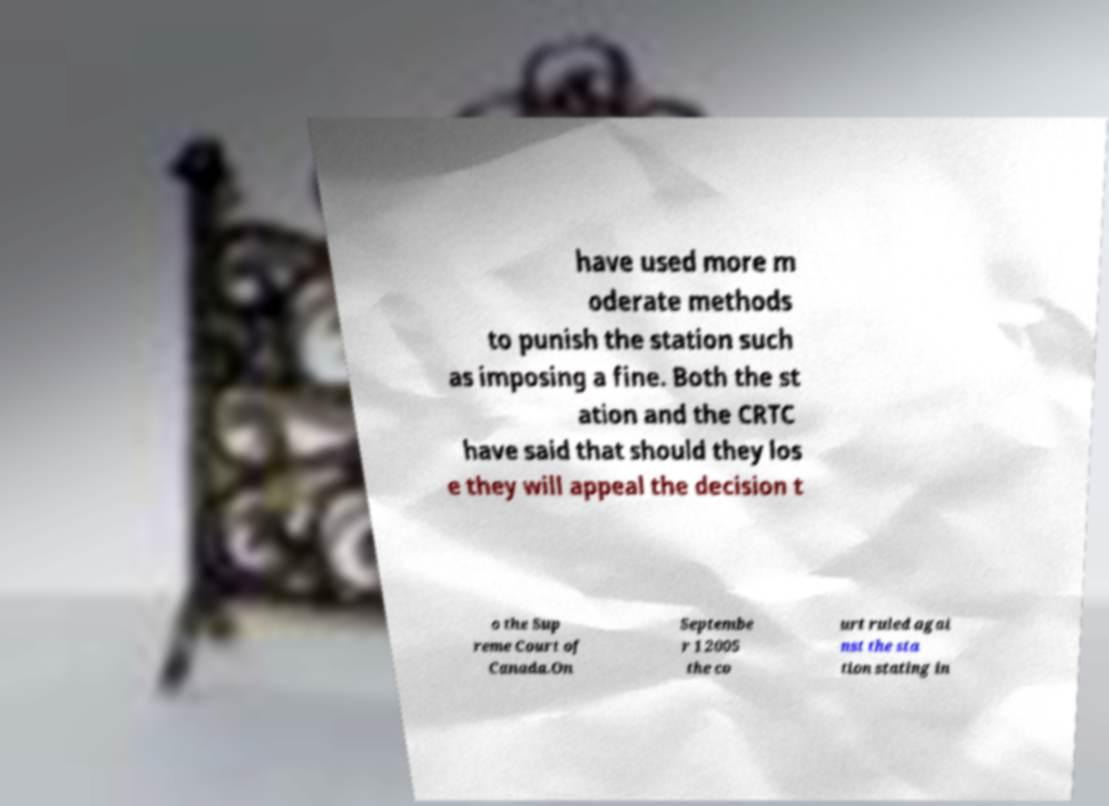Please read and relay the text visible in this image. What does it say? have used more m oderate methods to punish the station such as imposing a fine. Both the st ation and the CRTC have said that should they los e they will appeal the decision t o the Sup reme Court of Canada.On Septembe r 1 2005 the co urt ruled agai nst the sta tion stating in 